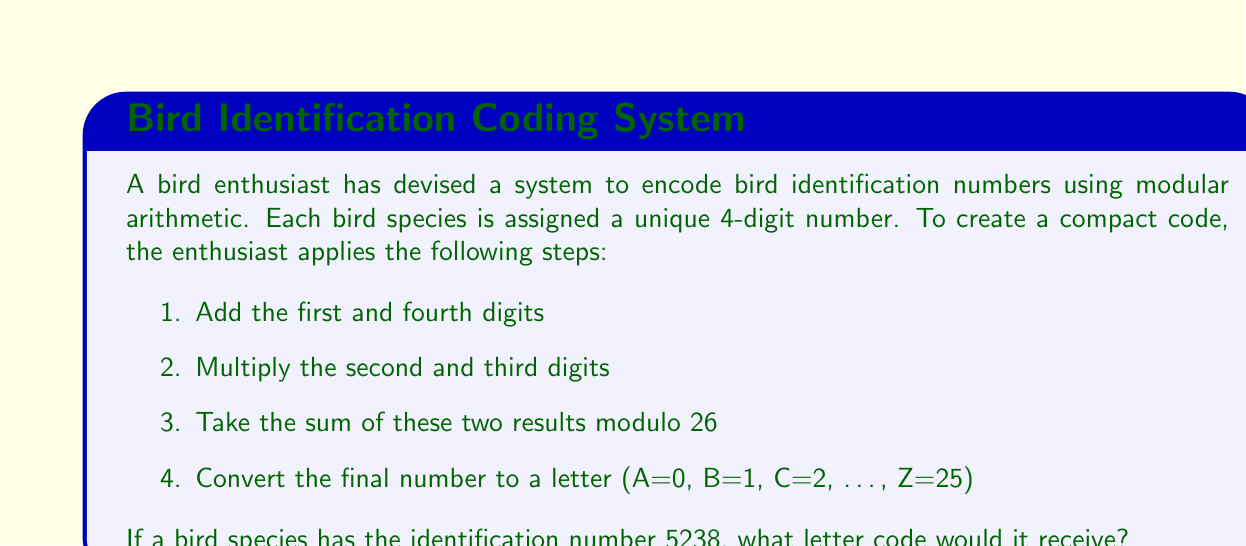Help me with this question. Let's follow the steps to solve this problem:

1. Add the first and fourth digits:
   $5 + 8 = 13$

2. Multiply the second and third digits:
   $2 \times 3 = 6$

3. Sum the results from steps 1 and 2:
   $13 + 6 = 19$

4. Take this sum modulo 26:
   $19 \bmod 26 = 19$

5. Convert the result to a letter:
   Since A=0, B=1, C=2, ..., we need to add 1 to our result to get the correct letter position.
   $19 + 1 = 20$

   The 20th letter of the alphabet is T.

Therefore, the bird species with identification number 5238 would receive the letter code T.
Answer: T 